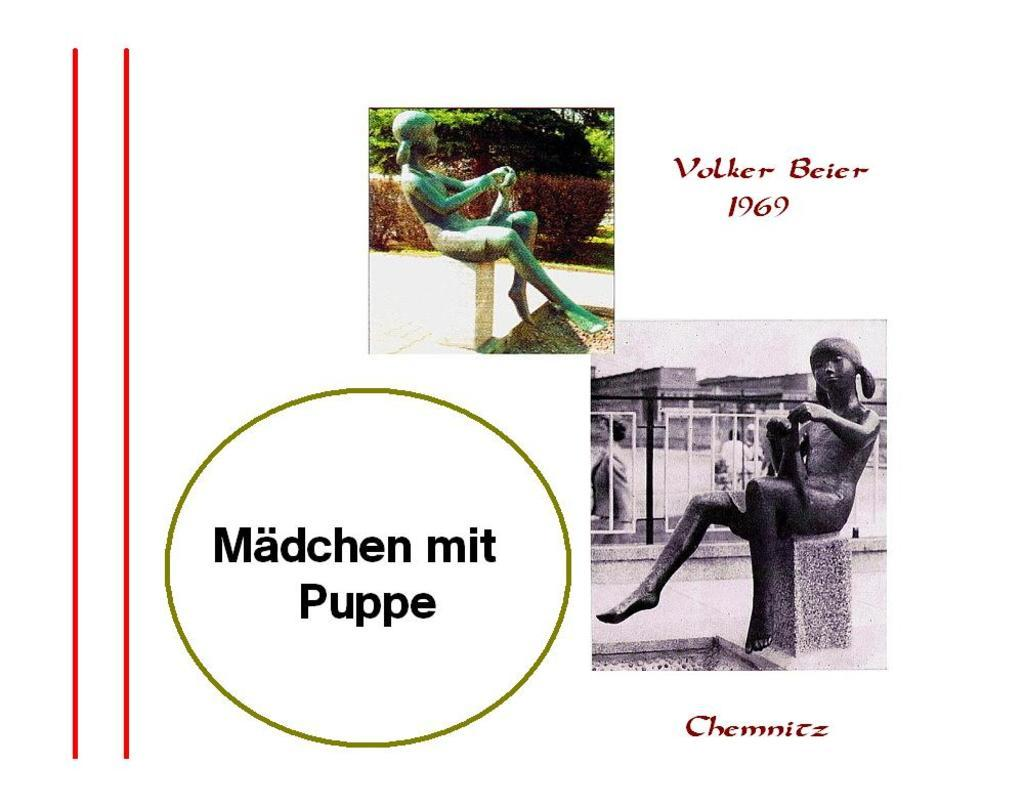What can be seen in the image that resembles art? There are sculptures in the image. What are the sculptures doing with their hands? The sculptures are holding objects. Is there any text present in the image? Yes, there is text in the image. How many cacti are present in the image? There are no cacti visible in the image. What type of division is taking place in the image? There is no division or separation occurring in the image. 